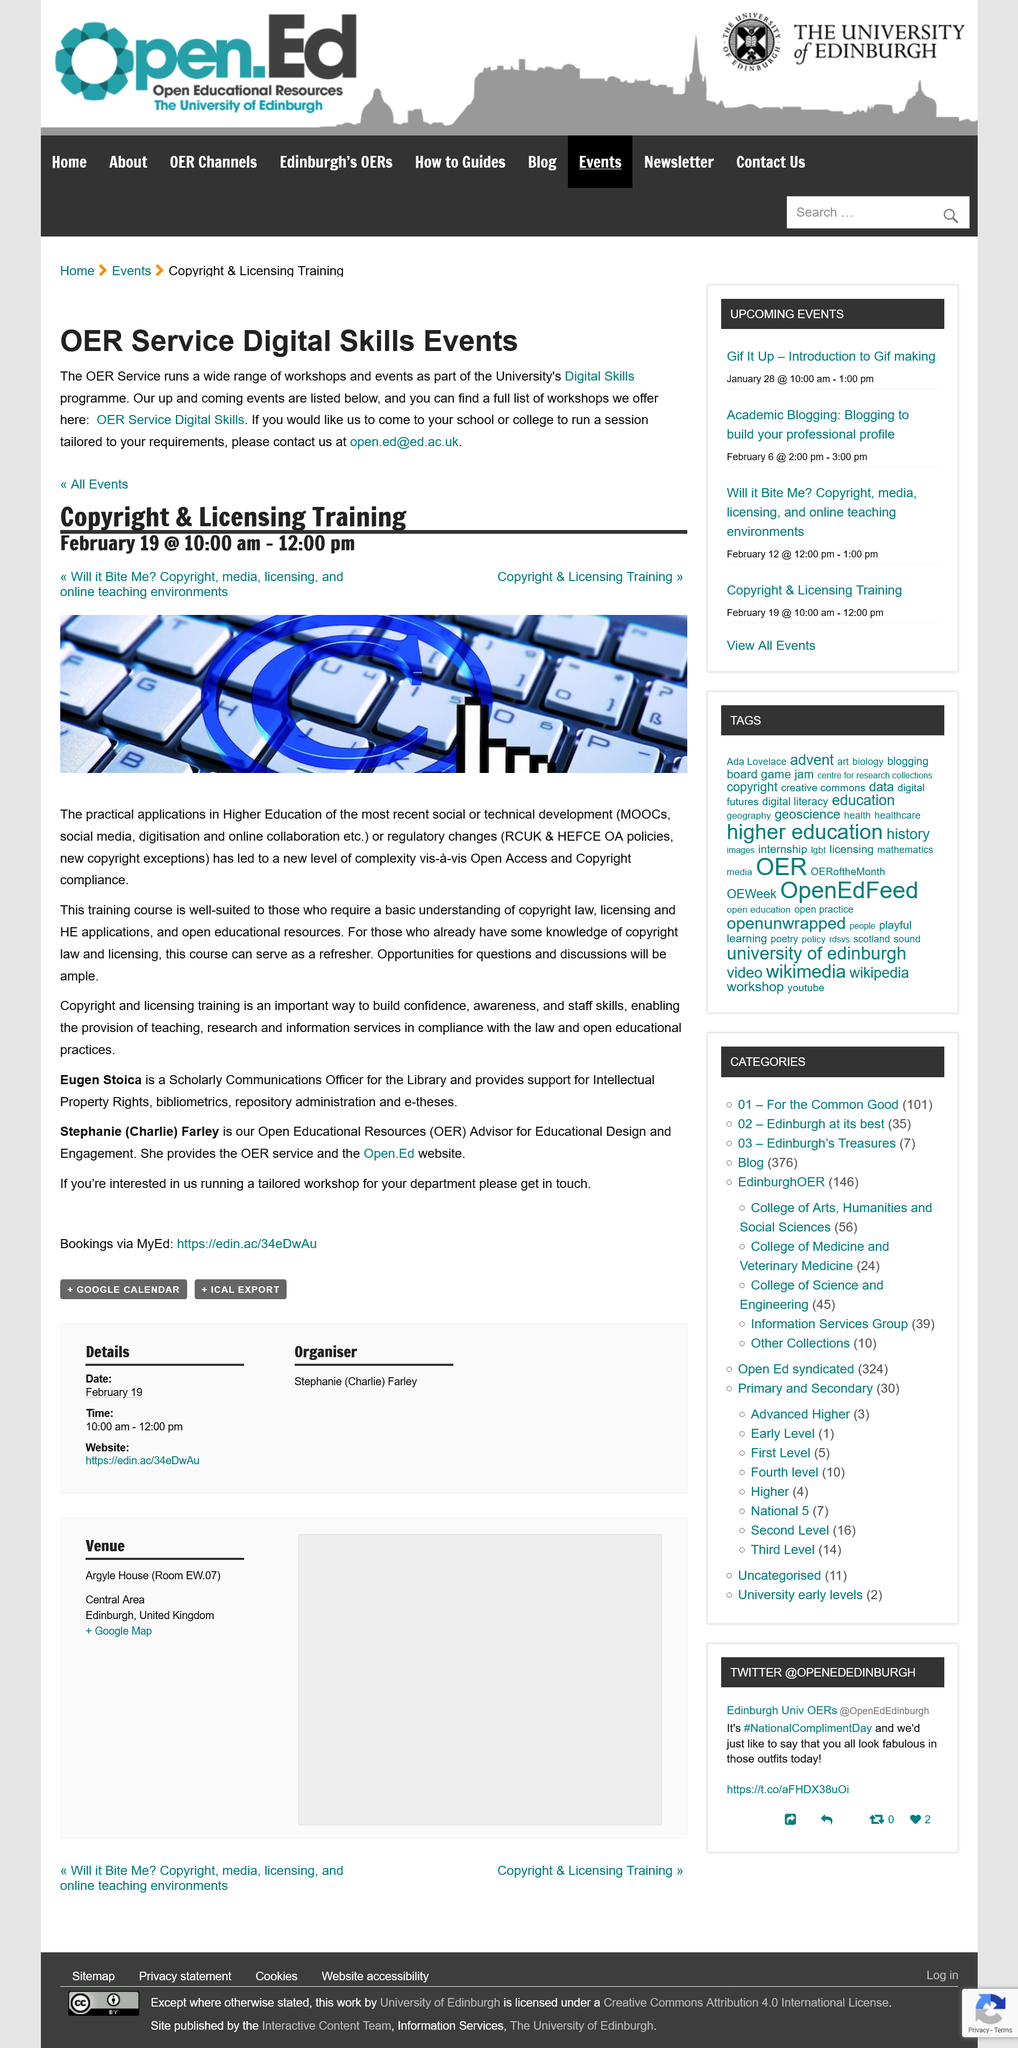Draw attention to some important aspects in this diagram. The copyright and licensing training will be held on February 19th from 10:00 am to 12:00 pm. The events in the OER Service Digital Skills Program are designed to provide participants with a comprehensive understanding of the latest digital skills and technologies. This OER Service is part of the University's Digital Skills program, which is a comprehensive initiative aimed at enhancing the digital proficiency of the institution's community. Eugen Stoica is a scholarly communications officer. Open Educational Resources" is the acronym for OER. 